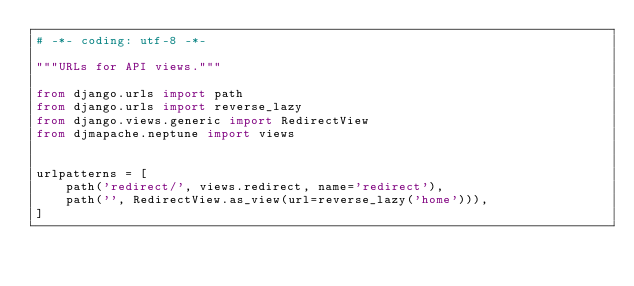<code> <loc_0><loc_0><loc_500><loc_500><_Python_># -*- coding: utf-8 -*-

"""URLs for API views."""

from django.urls import path
from django.urls import reverse_lazy
from django.views.generic import RedirectView
from djmapache.neptune import views


urlpatterns = [
    path('redirect/', views.redirect, name='redirect'),
    path('', RedirectView.as_view(url=reverse_lazy('home'))),
]
</code> 